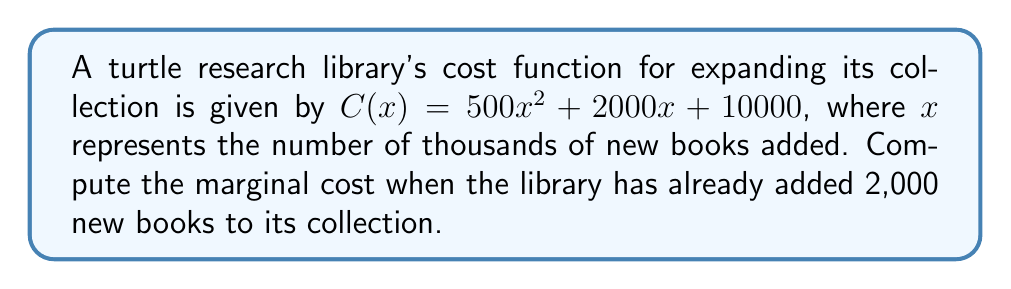Show me your answer to this math problem. To solve this problem, we'll follow these steps:

1) The marginal cost is given by the derivative of the cost function $C(x)$.

2) Let's find the derivative of $C(x)$:
   $$C'(x) = \frac{d}{dx}(500x^2 + 2000x + 10000)$$
   $$C'(x) = 1000x + 2000$$

3) This derivative function $C'(x)$ represents the marginal cost.

4) We need to find the marginal cost when 2,000 books have been added. This is equivalent to $x = 2$ (since $x$ is in thousands of books).

5) Let's substitute $x = 2$ into our marginal cost function:
   $$C'(2) = 1000(2) + 2000$$
   $$C'(2) = 2000 + 2000 = 4000$$

6) Therefore, the marginal cost when 2,000 books have been added is $4,000.

Note: This means that at the point where 2,000 books have been added, the cost of adding one more book is approximately $4.
Answer: $4,000 